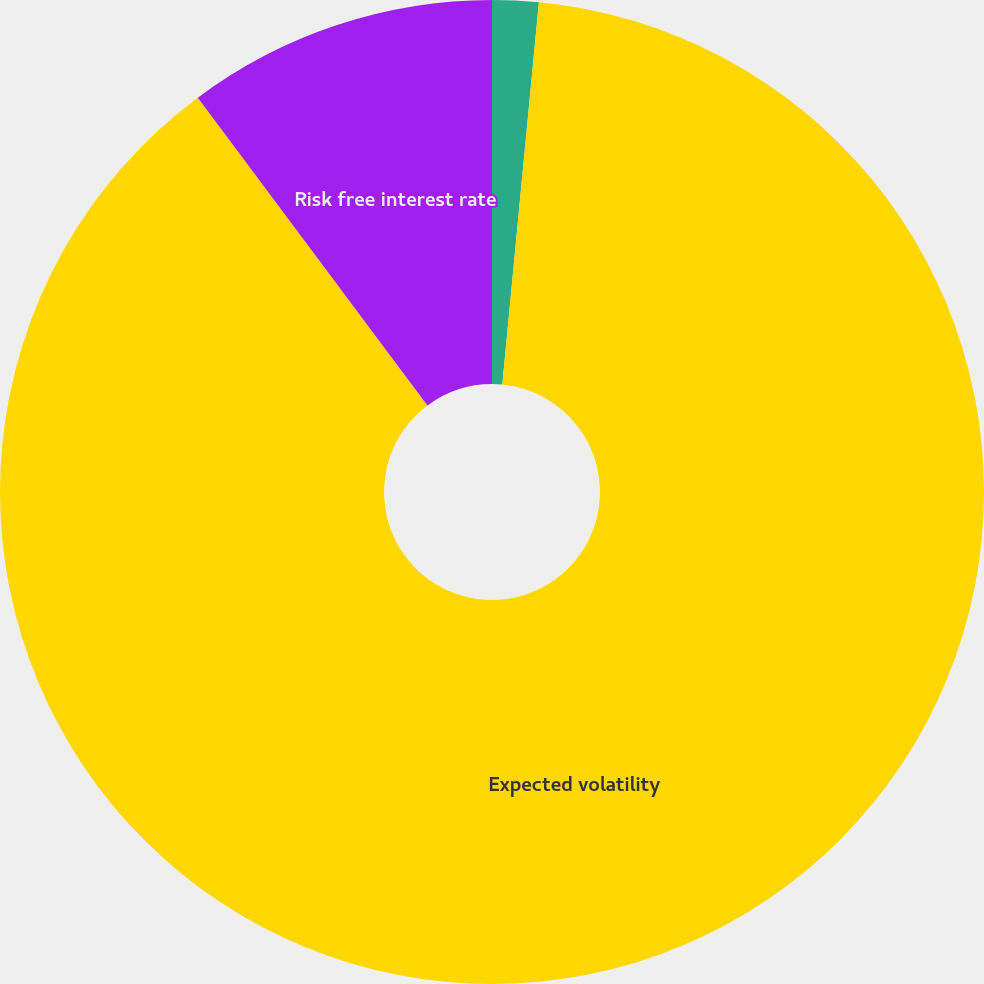<chart> <loc_0><loc_0><loc_500><loc_500><pie_chart><fcel>Dividend yield<fcel>Expected volatility<fcel>Risk free interest rate<nl><fcel>1.52%<fcel>88.27%<fcel>10.2%<nl></chart> 